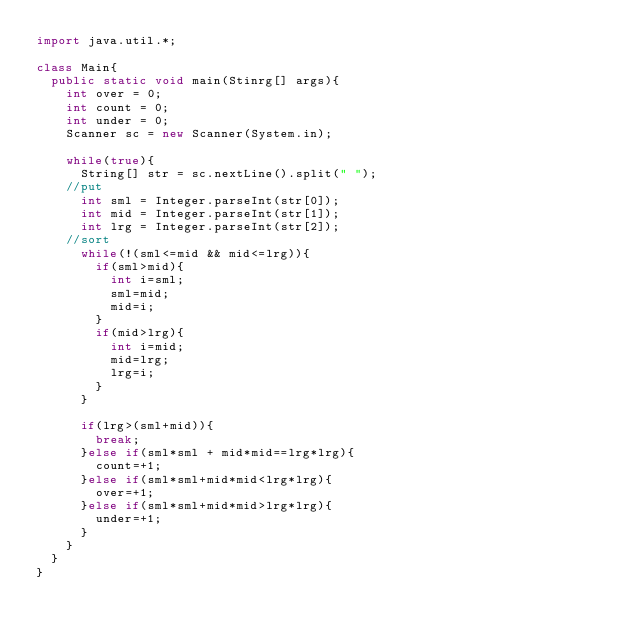<code> <loc_0><loc_0><loc_500><loc_500><_Java_>import java.util.*;

class Main{
	public static void main(Stinrg[] args){
		int over = 0;
		int count = 0;
		int under = 0;
		Scanner sc = new Scanner(System.in);
		
		while(true){
			String[] str = sc.nextLine().split(" ");
		//put	
			int sml = Integer.parseInt(str[0]);
			int mid = Integer.parseInt(str[1]);
			int lrg = Integer.parseInt(str[2]);
		//sort	
			while(!(sml<=mid && mid<=lrg)){
				if(sml>mid){
					int i=sml;
					sml=mid;
					mid=i;
				}
				if(mid>lrg){
					int i=mid;
					mid=lrg;
					lrg=i;
				}
			}
			
			if(lrg>(sml+mid)){
				break;
			}else if(sml*sml + mid*mid==lrg*lrg){
				count=+1;
			}else if(sml*sml+mid*mid<lrg*lrg){
				over=+1;
			}else if(sml*sml+mid*mid>lrg*lrg){
				under=+1;
			}
		}
	}
}
</code> 